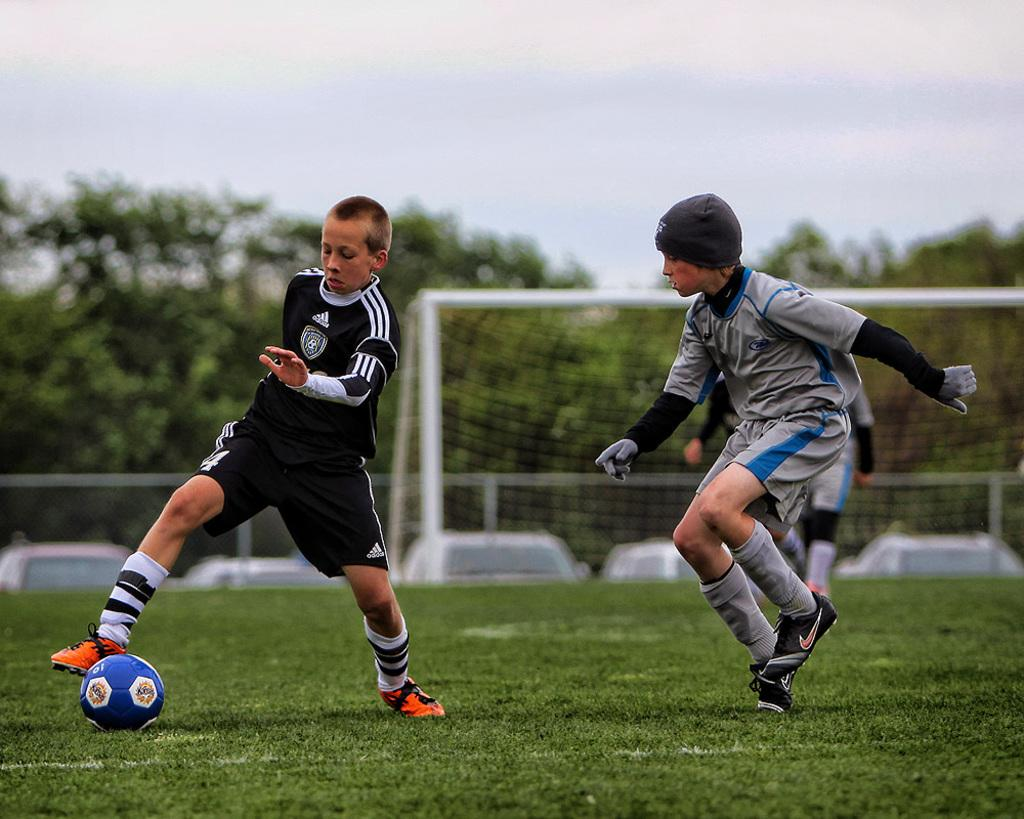How many boys are playing in the image? There are three boys playing in the image. What object are the boys playing with? There is a ball in the image. What type of surface are the boys playing on? There is grass in the image. What type of area is depicted in the image? There is a court in the image. What else can be seen in the image besides the boys and the ball? There is a vehicle and trees in the image. What is visible in the background of the image? The sky is visible in the image. What type of fork is being used by the boys to rate their performance in the image? There is no fork present in the image, nor is there any indication that the boys are rating their performance. 